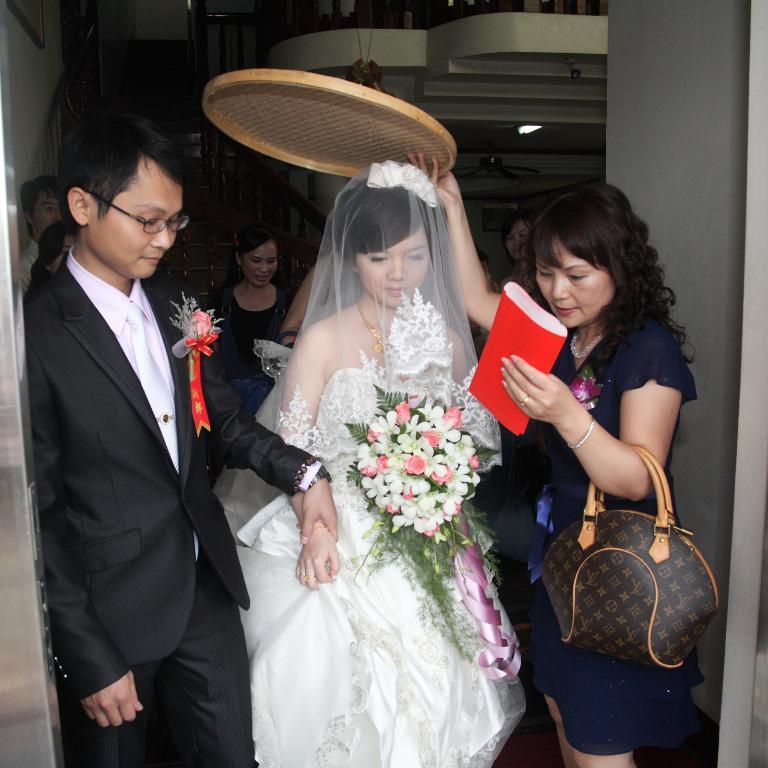Describe this image in one or two sentences. On the right side of the image we can see a woman is holding a cover and handbag in her hand. We can see a woman wearing white dress is holding a bouquet in her hand. On the left side of the image we can see a man wearing black blazer. In the background we can see few people, stairs and ceiling fan. 